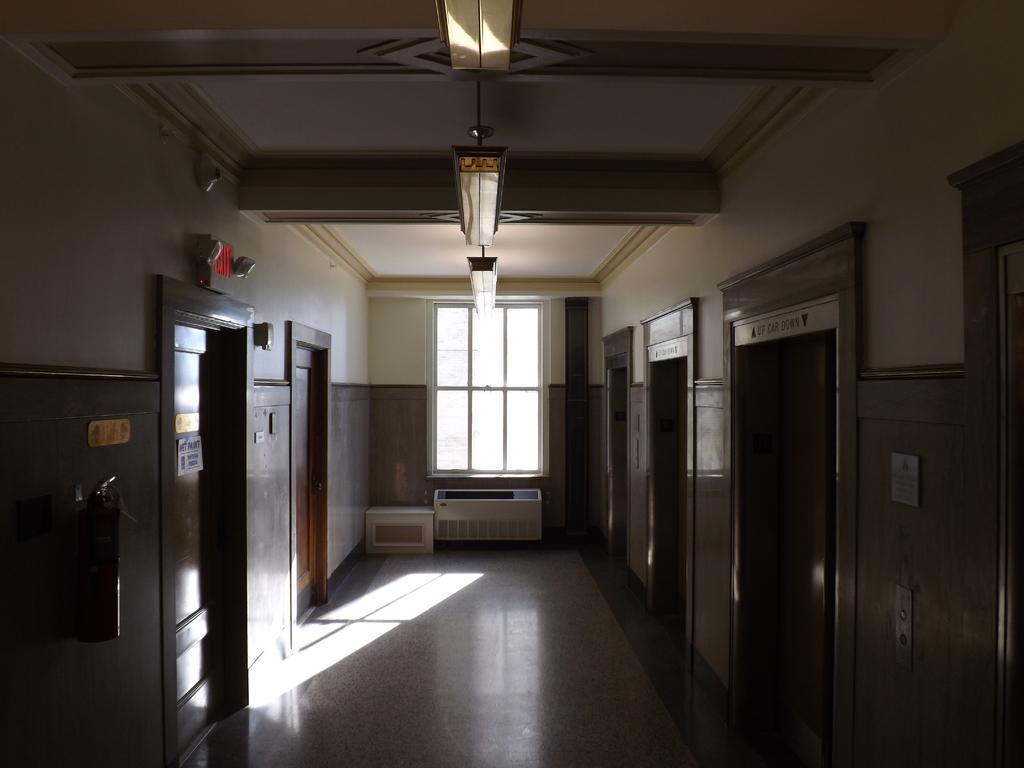How would you summarize this image in a sentence or two? This is an inner view of a building containing some doors, signboards, some devices, the fire extinguisher, some boards on a wall, a window and a roof with some ceiling lights. 